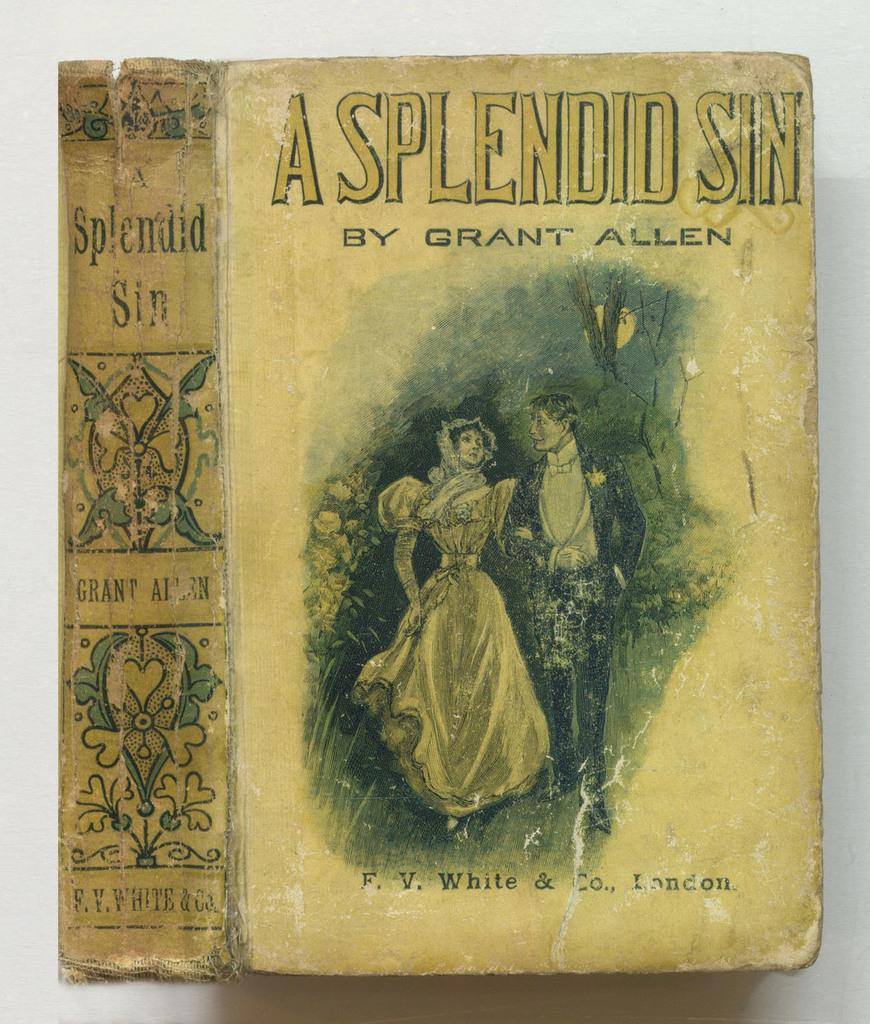Provide a one-sentence caption for the provided image. A cover of an old book called A Splendid Sin. 